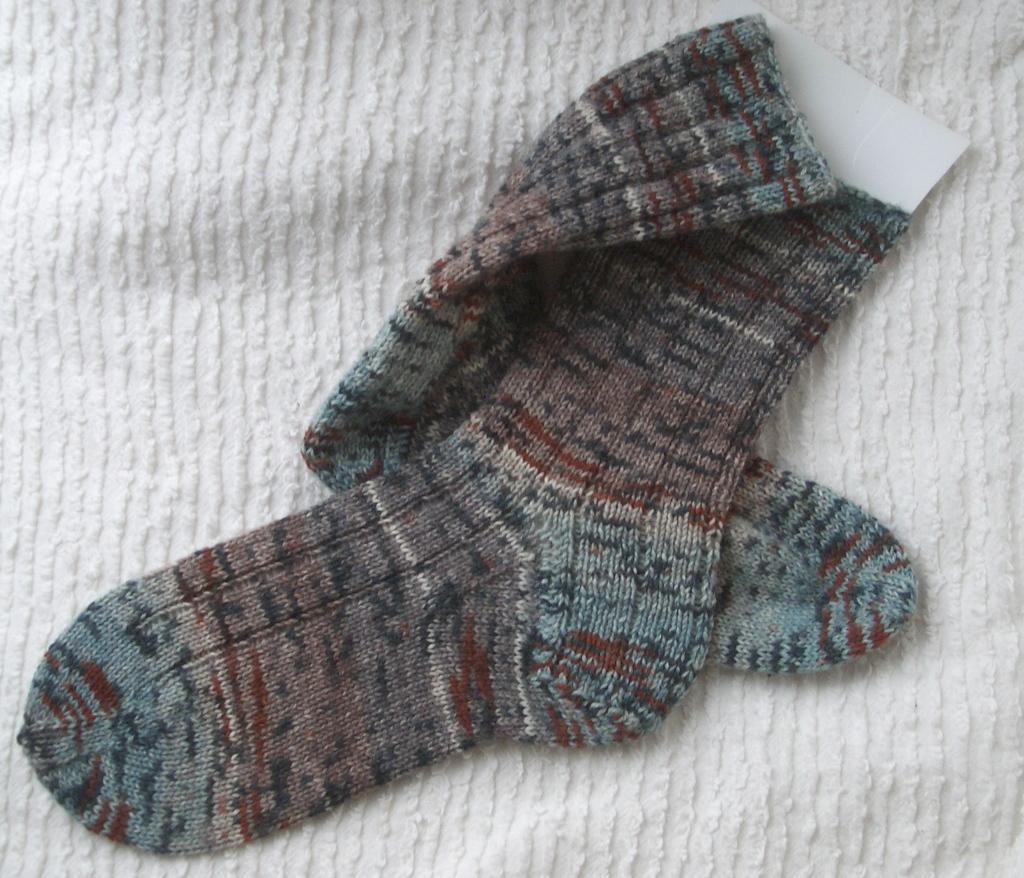Please provide a concise description of this image. As we can see in the image there are socks and white color cloth. 